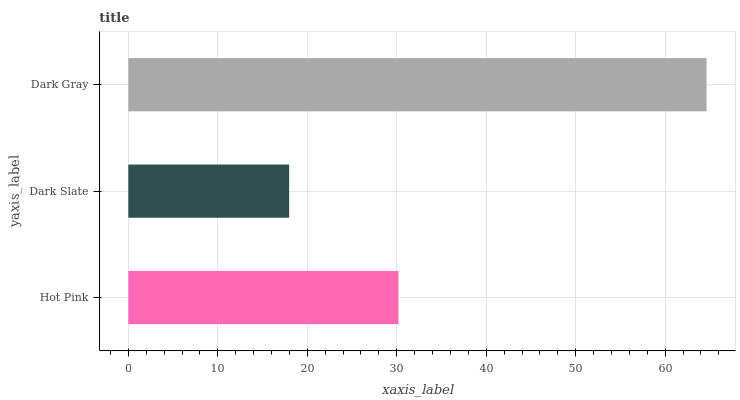Is Dark Slate the minimum?
Answer yes or no. Yes. Is Dark Gray the maximum?
Answer yes or no. Yes. Is Dark Gray the minimum?
Answer yes or no. No. Is Dark Slate the maximum?
Answer yes or no. No. Is Dark Gray greater than Dark Slate?
Answer yes or no. Yes. Is Dark Slate less than Dark Gray?
Answer yes or no. Yes. Is Dark Slate greater than Dark Gray?
Answer yes or no. No. Is Dark Gray less than Dark Slate?
Answer yes or no. No. Is Hot Pink the high median?
Answer yes or no. Yes. Is Hot Pink the low median?
Answer yes or no. Yes. Is Dark Gray the high median?
Answer yes or no. No. Is Dark Slate the low median?
Answer yes or no. No. 